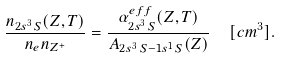Convert formula to latex. <formula><loc_0><loc_0><loc_500><loc_500>\frac { n _ { 2 s ^ { 3 } \, S } ( Z , T ) } { n _ { e } n _ { Z ^ { + } } } = \frac { \alpha ^ { e f f } _ { 2 s ^ { 3 } \, S } ( Z , T ) } { A _ { 2 s ^ { 3 } \, S - 1 s ^ { 1 } \, S } ( Z ) } \ \ [ c m ^ { 3 } ] .</formula> 